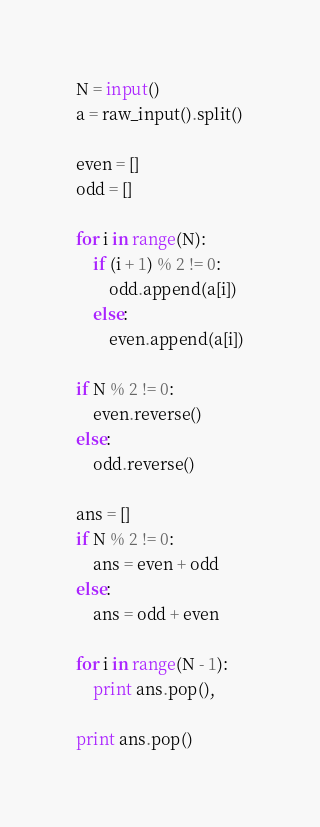Convert code to text. <code><loc_0><loc_0><loc_500><loc_500><_Python_>N = input()
a = raw_input().split()

even = []
odd = []

for i in range(N):
    if (i + 1) % 2 != 0:
        odd.append(a[i])
    else:
        even.append(a[i])

if N % 2 != 0:
    even.reverse()
else:
    odd.reverse()

ans = []
if N % 2 != 0:
    ans = even + odd
else:
    ans = odd + even

for i in range(N - 1):
    print ans.pop(),

print ans.pop()
</code> 